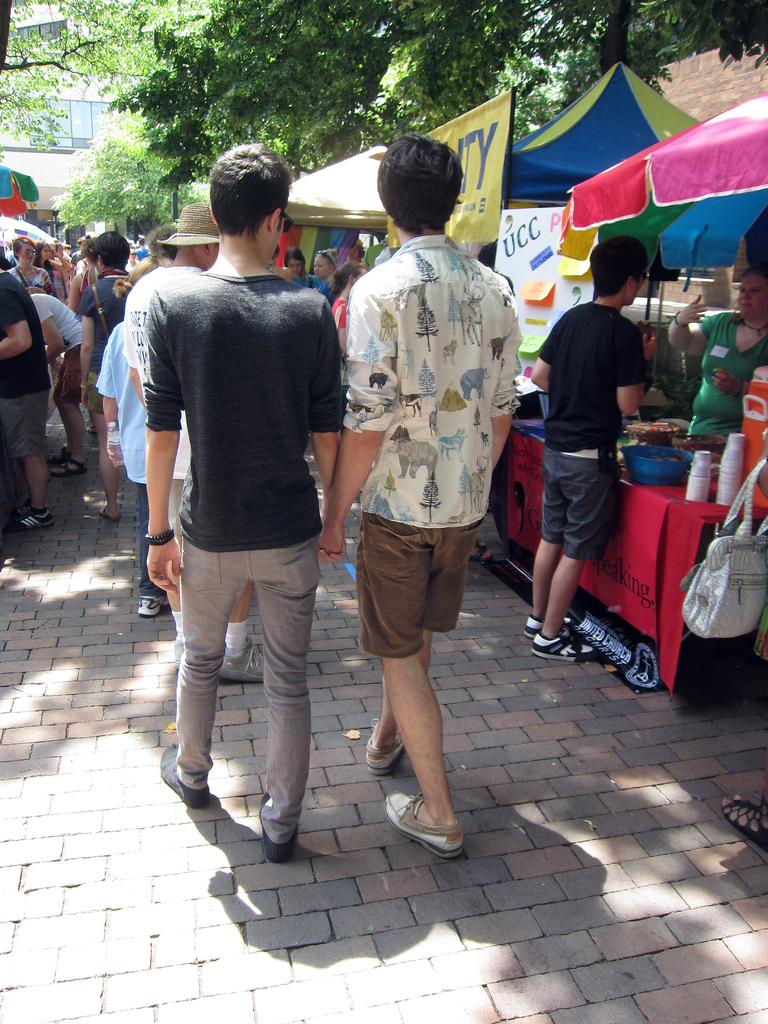Who or what can be seen in the image? There are people in the image. What type of structures are present in the image? There are stalls in the image. What can be seen in the distance in the image? There are trees and a building in the background of the image. What are the boards used for in the image? The boards are used for displaying information or advertisements in the image. What is placed on the table in the image? There are things placed on a table in the image, but the specific items are not mentioned in the facts. What type of bell can be heard ringing in the image? There is no bell present or mentioned in the image, so it cannot be heard ringing. 